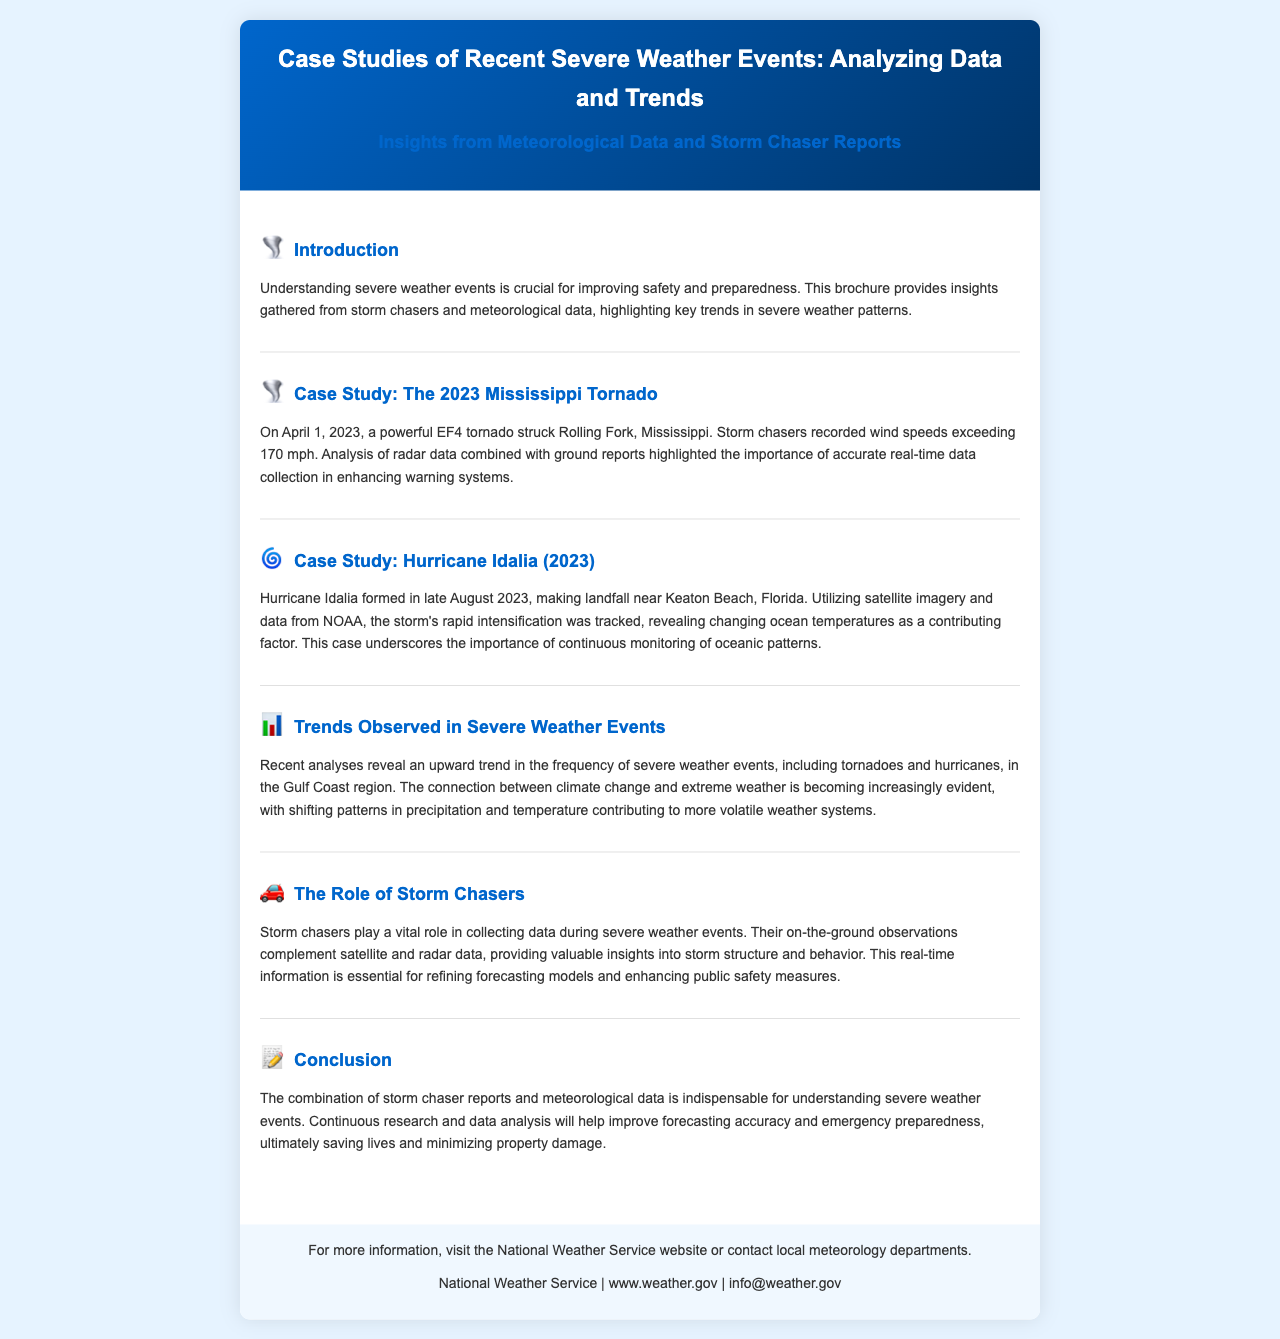What was the intensity of the 2023 Mississippi Tornado? The tornado was classified as an EF4, indicating a high-intensity storm.
Answer: EF4 When did Hurricane Idalia make landfall? The document states Hurricane Idalia made landfall in late August 2023.
Answer: Late August 2023 What was a significant factor contributing to Hurricane Idalia's rapid intensification? The document mentions changing ocean temperatures as a factor.
Answer: Changing ocean temperatures What pattern is observed in the frequency of severe weather events? The document indicates an upward trend in the frequency.
Answer: Upward trend What role do storm chasers play during severe weather events? Storm chasers collect data that complements meteorological observations.
Answer: Collect data What organization is mentioned for more information at the end of the brochure? The National Weather Service is mentioned as a source for additional information.
Answer: National Weather Service What does the document emphasize as essential for refining forecasting models? Real-time information from storm chasers is emphasized as essential.
Answer: Real-time information What type of weather event is explicitly noted in the case study section related to Mississippi? The event discussed is a tornado.
Answer: Tornado Which section of the document discusses trends in severe weather events? The section titled "Trends Observed in Severe Weather Events" addresses this topic.
Answer: Trends Observed in Severe Weather Events 